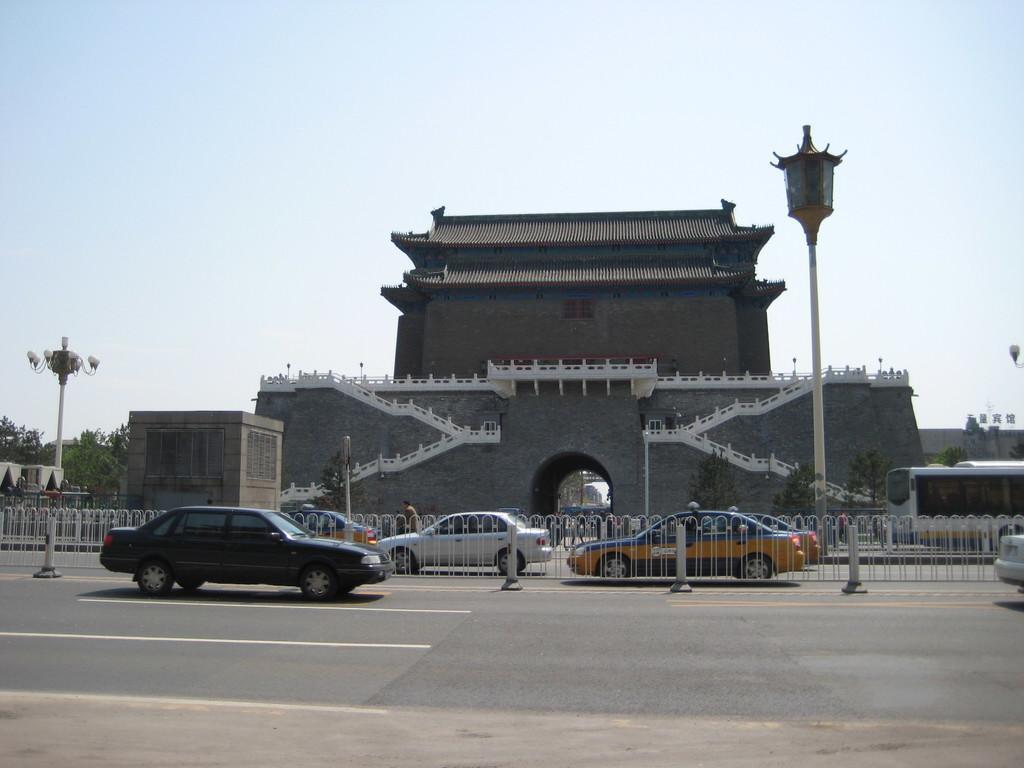Can you describe this image briefly? In this image I see a building over here and I see the road on which there are few vehicles and I see the fencing and I see 2 poles. In the background I see the trees and the sky and I see few people. 